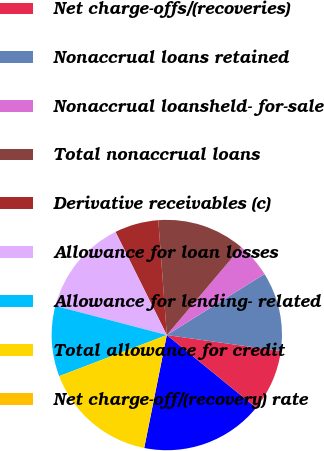Convert chart to OTSL. <chart><loc_0><loc_0><loc_500><loc_500><pie_chart><fcel>and where otherwise noted)<fcel>Net charge-offs/(recoveries)<fcel>Nonaccrual loans retained<fcel>Nonaccrual loansheld- for-sale<fcel>Total nonaccrual loans<fcel>Derivative receivables (c)<fcel>Allowance for loan losses<fcel>Allowance for lending- related<fcel>Total allowance for credit<fcel>Net charge-off/(recovery) rate<nl><fcel>17.28%<fcel>8.64%<fcel>11.11%<fcel>4.94%<fcel>12.35%<fcel>6.17%<fcel>13.58%<fcel>9.88%<fcel>16.05%<fcel>0.0%<nl></chart> 